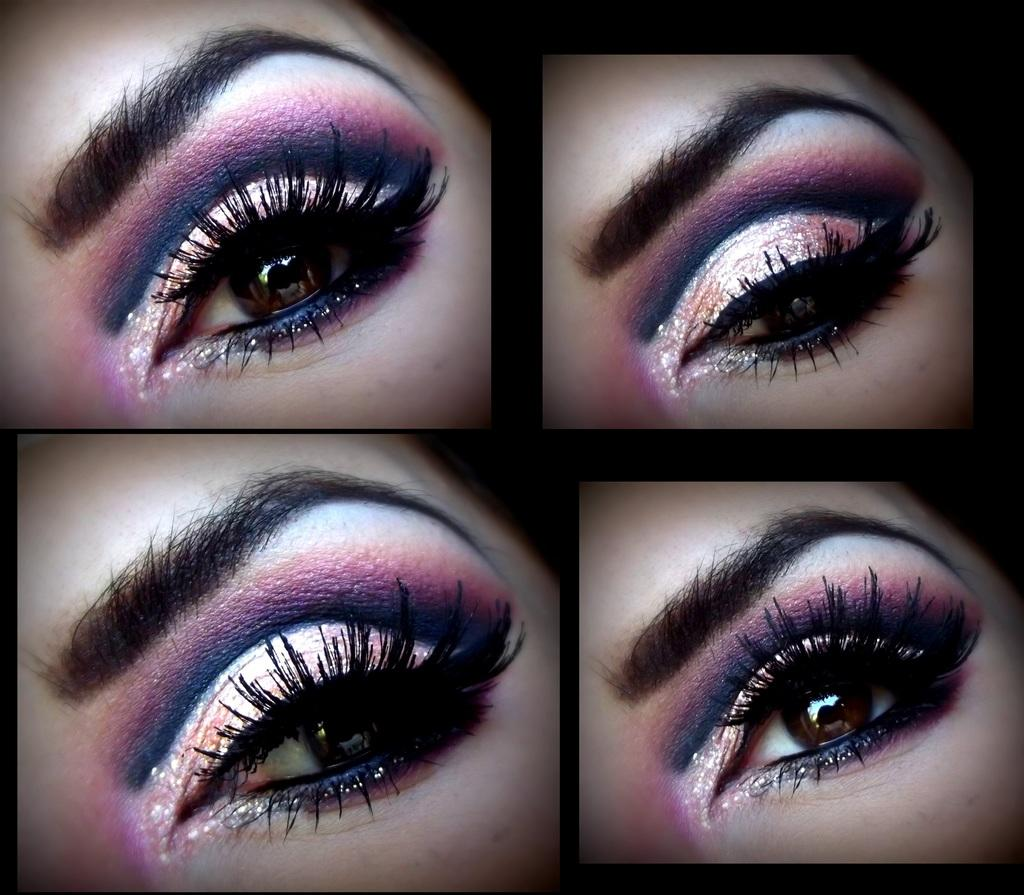What can be seen in the image that is related to vision? There are eyes visible in the image. What type of image is present in the collage? There is a collage photo in the image. What type of smell can be detected from the image? There is no smell associated with the image, as it is a visual medium. What type of jewel is present in the image? There is no mention of a jewel in the provided facts, so we cannot determine if one is present in the image. 